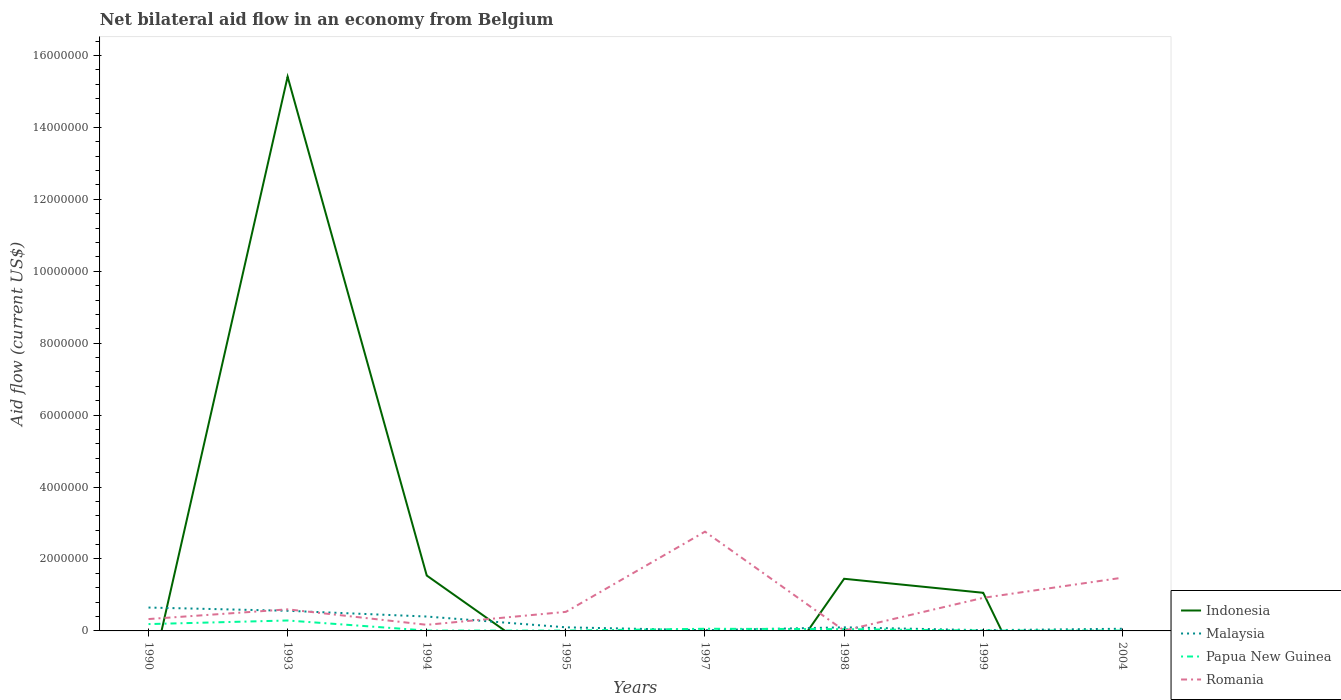Does the line corresponding to Papua New Guinea intersect with the line corresponding to Romania?
Ensure brevity in your answer.  Yes. Across all years, what is the maximum net bilateral aid flow in Malaysia?
Provide a short and direct response. 2.00e+04. What is the total net bilateral aid flow in Indonesia in the graph?
Your answer should be very brief. 9.00e+04. What is the difference between the highest and the second highest net bilateral aid flow in Papua New Guinea?
Your answer should be very brief. 2.80e+05. Is the net bilateral aid flow in Romania strictly greater than the net bilateral aid flow in Papua New Guinea over the years?
Your answer should be very brief. No. How many years are there in the graph?
Your response must be concise. 8. What is the difference between two consecutive major ticks on the Y-axis?
Make the answer very short. 2.00e+06. Are the values on the major ticks of Y-axis written in scientific E-notation?
Your answer should be compact. No. What is the title of the graph?
Your response must be concise. Net bilateral aid flow in an economy from Belgium. Does "Cabo Verde" appear as one of the legend labels in the graph?
Your answer should be very brief. No. What is the label or title of the X-axis?
Provide a short and direct response. Years. What is the Aid flow (current US$) in Indonesia in 1990?
Provide a succinct answer. 0. What is the Aid flow (current US$) in Malaysia in 1990?
Your answer should be very brief. 6.50e+05. What is the Aid flow (current US$) of Indonesia in 1993?
Your answer should be very brief. 1.54e+07. What is the Aid flow (current US$) of Malaysia in 1993?
Provide a succinct answer. 5.60e+05. What is the Aid flow (current US$) of Papua New Guinea in 1993?
Ensure brevity in your answer.  2.90e+05. What is the Aid flow (current US$) of Indonesia in 1994?
Your response must be concise. 1.54e+06. What is the Aid flow (current US$) of Romania in 1994?
Your answer should be very brief. 1.70e+05. What is the Aid flow (current US$) of Indonesia in 1995?
Provide a short and direct response. 0. What is the Aid flow (current US$) of Papua New Guinea in 1995?
Your answer should be very brief. 10000. What is the Aid flow (current US$) of Romania in 1995?
Offer a very short reply. 5.30e+05. What is the Aid flow (current US$) in Romania in 1997?
Your response must be concise. 2.76e+06. What is the Aid flow (current US$) of Indonesia in 1998?
Offer a very short reply. 1.45e+06. What is the Aid flow (current US$) in Romania in 1998?
Offer a very short reply. 10000. What is the Aid flow (current US$) of Indonesia in 1999?
Offer a terse response. 1.06e+06. What is the Aid flow (current US$) of Romania in 1999?
Your answer should be compact. 9.20e+05. What is the Aid flow (current US$) in Indonesia in 2004?
Ensure brevity in your answer.  0. What is the Aid flow (current US$) in Malaysia in 2004?
Offer a very short reply. 6.00e+04. What is the Aid flow (current US$) of Romania in 2004?
Make the answer very short. 1.48e+06. Across all years, what is the maximum Aid flow (current US$) in Indonesia?
Provide a succinct answer. 1.54e+07. Across all years, what is the maximum Aid flow (current US$) of Malaysia?
Keep it short and to the point. 6.50e+05. Across all years, what is the maximum Aid flow (current US$) in Papua New Guinea?
Give a very brief answer. 2.90e+05. Across all years, what is the maximum Aid flow (current US$) in Romania?
Offer a terse response. 2.76e+06. Across all years, what is the minimum Aid flow (current US$) of Papua New Guinea?
Provide a short and direct response. 10000. What is the total Aid flow (current US$) in Indonesia in the graph?
Offer a very short reply. 1.95e+07. What is the total Aid flow (current US$) of Malaysia in the graph?
Your answer should be very brief. 1.91e+06. What is the total Aid flow (current US$) in Papua New Guinea in the graph?
Provide a succinct answer. 6.30e+05. What is the total Aid flow (current US$) in Romania in the graph?
Provide a succinct answer. 6.80e+06. What is the difference between the Aid flow (current US$) in Papua New Guinea in 1990 and that in 1993?
Your answer should be compact. -1.00e+05. What is the difference between the Aid flow (current US$) of Malaysia in 1990 and that in 1995?
Your response must be concise. 5.50e+05. What is the difference between the Aid flow (current US$) in Romania in 1990 and that in 1995?
Offer a very short reply. -2.00e+05. What is the difference between the Aid flow (current US$) in Malaysia in 1990 and that in 1997?
Offer a terse response. 6.30e+05. What is the difference between the Aid flow (current US$) of Romania in 1990 and that in 1997?
Your answer should be compact. -2.43e+06. What is the difference between the Aid flow (current US$) in Malaysia in 1990 and that in 1999?
Offer a terse response. 6.30e+05. What is the difference between the Aid flow (current US$) of Romania in 1990 and that in 1999?
Give a very brief answer. -5.90e+05. What is the difference between the Aid flow (current US$) of Malaysia in 1990 and that in 2004?
Provide a short and direct response. 5.90e+05. What is the difference between the Aid flow (current US$) in Romania in 1990 and that in 2004?
Your answer should be compact. -1.15e+06. What is the difference between the Aid flow (current US$) in Indonesia in 1993 and that in 1994?
Ensure brevity in your answer.  1.39e+07. What is the difference between the Aid flow (current US$) in Papua New Guinea in 1993 and that in 1994?
Ensure brevity in your answer.  2.80e+05. What is the difference between the Aid flow (current US$) of Romania in 1993 and that in 1994?
Keep it short and to the point. 4.30e+05. What is the difference between the Aid flow (current US$) in Malaysia in 1993 and that in 1997?
Offer a terse response. 5.40e+05. What is the difference between the Aid flow (current US$) in Papua New Guinea in 1993 and that in 1997?
Provide a short and direct response. 2.30e+05. What is the difference between the Aid flow (current US$) in Romania in 1993 and that in 1997?
Offer a very short reply. -2.16e+06. What is the difference between the Aid flow (current US$) of Indonesia in 1993 and that in 1998?
Your answer should be very brief. 1.40e+07. What is the difference between the Aid flow (current US$) in Papua New Guinea in 1993 and that in 1998?
Ensure brevity in your answer.  2.40e+05. What is the difference between the Aid flow (current US$) in Romania in 1993 and that in 1998?
Your answer should be very brief. 5.90e+05. What is the difference between the Aid flow (current US$) in Indonesia in 1993 and that in 1999?
Ensure brevity in your answer.  1.44e+07. What is the difference between the Aid flow (current US$) of Malaysia in 1993 and that in 1999?
Your answer should be compact. 5.40e+05. What is the difference between the Aid flow (current US$) of Romania in 1993 and that in 1999?
Keep it short and to the point. -3.20e+05. What is the difference between the Aid flow (current US$) of Papua New Guinea in 1993 and that in 2004?
Offer a very short reply. 2.80e+05. What is the difference between the Aid flow (current US$) of Romania in 1993 and that in 2004?
Provide a succinct answer. -8.80e+05. What is the difference between the Aid flow (current US$) of Papua New Guinea in 1994 and that in 1995?
Give a very brief answer. 0. What is the difference between the Aid flow (current US$) in Romania in 1994 and that in 1995?
Offer a very short reply. -3.60e+05. What is the difference between the Aid flow (current US$) in Romania in 1994 and that in 1997?
Provide a short and direct response. -2.59e+06. What is the difference between the Aid flow (current US$) of Indonesia in 1994 and that in 1998?
Your answer should be very brief. 9.00e+04. What is the difference between the Aid flow (current US$) in Romania in 1994 and that in 1998?
Offer a very short reply. 1.60e+05. What is the difference between the Aid flow (current US$) in Indonesia in 1994 and that in 1999?
Provide a short and direct response. 4.80e+05. What is the difference between the Aid flow (current US$) in Malaysia in 1994 and that in 1999?
Provide a succinct answer. 3.80e+05. What is the difference between the Aid flow (current US$) in Papua New Guinea in 1994 and that in 1999?
Your answer should be compact. 0. What is the difference between the Aid flow (current US$) of Romania in 1994 and that in 1999?
Keep it short and to the point. -7.50e+05. What is the difference between the Aid flow (current US$) of Malaysia in 1994 and that in 2004?
Your answer should be compact. 3.40e+05. What is the difference between the Aid flow (current US$) in Romania in 1994 and that in 2004?
Provide a succinct answer. -1.31e+06. What is the difference between the Aid flow (current US$) of Malaysia in 1995 and that in 1997?
Give a very brief answer. 8.00e+04. What is the difference between the Aid flow (current US$) of Papua New Guinea in 1995 and that in 1997?
Offer a very short reply. -5.00e+04. What is the difference between the Aid flow (current US$) of Romania in 1995 and that in 1997?
Give a very brief answer. -2.23e+06. What is the difference between the Aid flow (current US$) in Romania in 1995 and that in 1998?
Your answer should be compact. 5.20e+05. What is the difference between the Aid flow (current US$) of Malaysia in 1995 and that in 1999?
Your answer should be compact. 8.00e+04. What is the difference between the Aid flow (current US$) in Romania in 1995 and that in 1999?
Offer a terse response. -3.90e+05. What is the difference between the Aid flow (current US$) in Papua New Guinea in 1995 and that in 2004?
Keep it short and to the point. 0. What is the difference between the Aid flow (current US$) in Romania in 1995 and that in 2004?
Your answer should be very brief. -9.50e+05. What is the difference between the Aid flow (current US$) in Papua New Guinea in 1997 and that in 1998?
Provide a short and direct response. 10000. What is the difference between the Aid flow (current US$) in Romania in 1997 and that in 1998?
Ensure brevity in your answer.  2.75e+06. What is the difference between the Aid flow (current US$) in Romania in 1997 and that in 1999?
Ensure brevity in your answer.  1.84e+06. What is the difference between the Aid flow (current US$) in Malaysia in 1997 and that in 2004?
Your response must be concise. -4.00e+04. What is the difference between the Aid flow (current US$) in Romania in 1997 and that in 2004?
Offer a terse response. 1.28e+06. What is the difference between the Aid flow (current US$) of Indonesia in 1998 and that in 1999?
Keep it short and to the point. 3.90e+05. What is the difference between the Aid flow (current US$) of Malaysia in 1998 and that in 1999?
Offer a terse response. 8.00e+04. What is the difference between the Aid flow (current US$) of Romania in 1998 and that in 1999?
Offer a terse response. -9.10e+05. What is the difference between the Aid flow (current US$) in Romania in 1998 and that in 2004?
Give a very brief answer. -1.47e+06. What is the difference between the Aid flow (current US$) in Romania in 1999 and that in 2004?
Provide a succinct answer. -5.60e+05. What is the difference between the Aid flow (current US$) of Malaysia in 1990 and the Aid flow (current US$) of Papua New Guinea in 1993?
Offer a very short reply. 3.60e+05. What is the difference between the Aid flow (current US$) of Papua New Guinea in 1990 and the Aid flow (current US$) of Romania in 1993?
Your answer should be compact. -4.10e+05. What is the difference between the Aid flow (current US$) of Malaysia in 1990 and the Aid flow (current US$) of Papua New Guinea in 1994?
Your answer should be very brief. 6.40e+05. What is the difference between the Aid flow (current US$) of Malaysia in 1990 and the Aid flow (current US$) of Papua New Guinea in 1995?
Your answer should be very brief. 6.40e+05. What is the difference between the Aid flow (current US$) in Papua New Guinea in 1990 and the Aid flow (current US$) in Romania in 1995?
Your answer should be compact. -3.40e+05. What is the difference between the Aid flow (current US$) in Malaysia in 1990 and the Aid flow (current US$) in Papua New Guinea in 1997?
Ensure brevity in your answer.  5.90e+05. What is the difference between the Aid flow (current US$) in Malaysia in 1990 and the Aid flow (current US$) in Romania in 1997?
Your response must be concise. -2.11e+06. What is the difference between the Aid flow (current US$) in Papua New Guinea in 1990 and the Aid flow (current US$) in Romania in 1997?
Your answer should be very brief. -2.57e+06. What is the difference between the Aid flow (current US$) in Malaysia in 1990 and the Aid flow (current US$) in Romania in 1998?
Give a very brief answer. 6.40e+05. What is the difference between the Aid flow (current US$) of Papua New Guinea in 1990 and the Aid flow (current US$) of Romania in 1998?
Provide a succinct answer. 1.80e+05. What is the difference between the Aid flow (current US$) in Malaysia in 1990 and the Aid flow (current US$) in Papua New Guinea in 1999?
Give a very brief answer. 6.40e+05. What is the difference between the Aid flow (current US$) of Malaysia in 1990 and the Aid flow (current US$) of Romania in 1999?
Your answer should be very brief. -2.70e+05. What is the difference between the Aid flow (current US$) in Papua New Guinea in 1990 and the Aid flow (current US$) in Romania in 1999?
Offer a very short reply. -7.30e+05. What is the difference between the Aid flow (current US$) in Malaysia in 1990 and the Aid flow (current US$) in Papua New Guinea in 2004?
Your response must be concise. 6.40e+05. What is the difference between the Aid flow (current US$) of Malaysia in 1990 and the Aid flow (current US$) of Romania in 2004?
Your answer should be compact. -8.30e+05. What is the difference between the Aid flow (current US$) in Papua New Guinea in 1990 and the Aid flow (current US$) in Romania in 2004?
Offer a very short reply. -1.29e+06. What is the difference between the Aid flow (current US$) of Indonesia in 1993 and the Aid flow (current US$) of Malaysia in 1994?
Give a very brief answer. 1.50e+07. What is the difference between the Aid flow (current US$) in Indonesia in 1993 and the Aid flow (current US$) in Papua New Guinea in 1994?
Give a very brief answer. 1.54e+07. What is the difference between the Aid flow (current US$) in Indonesia in 1993 and the Aid flow (current US$) in Romania in 1994?
Give a very brief answer. 1.52e+07. What is the difference between the Aid flow (current US$) of Malaysia in 1993 and the Aid flow (current US$) of Papua New Guinea in 1994?
Give a very brief answer. 5.50e+05. What is the difference between the Aid flow (current US$) of Malaysia in 1993 and the Aid flow (current US$) of Romania in 1994?
Give a very brief answer. 3.90e+05. What is the difference between the Aid flow (current US$) of Papua New Guinea in 1993 and the Aid flow (current US$) of Romania in 1994?
Keep it short and to the point. 1.20e+05. What is the difference between the Aid flow (current US$) in Indonesia in 1993 and the Aid flow (current US$) in Malaysia in 1995?
Provide a short and direct response. 1.53e+07. What is the difference between the Aid flow (current US$) in Indonesia in 1993 and the Aid flow (current US$) in Papua New Guinea in 1995?
Offer a terse response. 1.54e+07. What is the difference between the Aid flow (current US$) in Indonesia in 1993 and the Aid flow (current US$) in Romania in 1995?
Provide a succinct answer. 1.49e+07. What is the difference between the Aid flow (current US$) in Malaysia in 1993 and the Aid flow (current US$) in Papua New Guinea in 1995?
Keep it short and to the point. 5.50e+05. What is the difference between the Aid flow (current US$) in Malaysia in 1993 and the Aid flow (current US$) in Romania in 1995?
Ensure brevity in your answer.  3.00e+04. What is the difference between the Aid flow (current US$) in Papua New Guinea in 1993 and the Aid flow (current US$) in Romania in 1995?
Keep it short and to the point. -2.40e+05. What is the difference between the Aid flow (current US$) in Indonesia in 1993 and the Aid flow (current US$) in Malaysia in 1997?
Your response must be concise. 1.54e+07. What is the difference between the Aid flow (current US$) of Indonesia in 1993 and the Aid flow (current US$) of Papua New Guinea in 1997?
Your answer should be very brief. 1.54e+07. What is the difference between the Aid flow (current US$) of Indonesia in 1993 and the Aid flow (current US$) of Romania in 1997?
Offer a very short reply. 1.26e+07. What is the difference between the Aid flow (current US$) in Malaysia in 1993 and the Aid flow (current US$) in Papua New Guinea in 1997?
Your response must be concise. 5.00e+05. What is the difference between the Aid flow (current US$) of Malaysia in 1993 and the Aid flow (current US$) of Romania in 1997?
Your response must be concise. -2.20e+06. What is the difference between the Aid flow (current US$) of Papua New Guinea in 1993 and the Aid flow (current US$) of Romania in 1997?
Provide a succinct answer. -2.47e+06. What is the difference between the Aid flow (current US$) in Indonesia in 1993 and the Aid flow (current US$) in Malaysia in 1998?
Your response must be concise. 1.53e+07. What is the difference between the Aid flow (current US$) of Indonesia in 1993 and the Aid flow (current US$) of Papua New Guinea in 1998?
Your answer should be compact. 1.54e+07. What is the difference between the Aid flow (current US$) in Indonesia in 1993 and the Aid flow (current US$) in Romania in 1998?
Offer a terse response. 1.54e+07. What is the difference between the Aid flow (current US$) of Malaysia in 1993 and the Aid flow (current US$) of Papua New Guinea in 1998?
Give a very brief answer. 5.10e+05. What is the difference between the Aid flow (current US$) in Malaysia in 1993 and the Aid flow (current US$) in Romania in 1998?
Provide a short and direct response. 5.50e+05. What is the difference between the Aid flow (current US$) in Indonesia in 1993 and the Aid flow (current US$) in Malaysia in 1999?
Keep it short and to the point. 1.54e+07. What is the difference between the Aid flow (current US$) of Indonesia in 1993 and the Aid flow (current US$) of Papua New Guinea in 1999?
Make the answer very short. 1.54e+07. What is the difference between the Aid flow (current US$) of Indonesia in 1993 and the Aid flow (current US$) of Romania in 1999?
Your answer should be compact. 1.45e+07. What is the difference between the Aid flow (current US$) in Malaysia in 1993 and the Aid flow (current US$) in Papua New Guinea in 1999?
Your response must be concise. 5.50e+05. What is the difference between the Aid flow (current US$) of Malaysia in 1993 and the Aid flow (current US$) of Romania in 1999?
Offer a very short reply. -3.60e+05. What is the difference between the Aid flow (current US$) in Papua New Guinea in 1993 and the Aid flow (current US$) in Romania in 1999?
Your answer should be very brief. -6.30e+05. What is the difference between the Aid flow (current US$) in Indonesia in 1993 and the Aid flow (current US$) in Malaysia in 2004?
Your answer should be compact. 1.54e+07. What is the difference between the Aid flow (current US$) of Indonesia in 1993 and the Aid flow (current US$) of Papua New Guinea in 2004?
Your response must be concise. 1.54e+07. What is the difference between the Aid flow (current US$) of Indonesia in 1993 and the Aid flow (current US$) of Romania in 2004?
Ensure brevity in your answer.  1.39e+07. What is the difference between the Aid flow (current US$) of Malaysia in 1993 and the Aid flow (current US$) of Papua New Guinea in 2004?
Your answer should be compact. 5.50e+05. What is the difference between the Aid flow (current US$) in Malaysia in 1993 and the Aid flow (current US$) in Romania in 2004?
Offer a very short reply. -9.20e+05. What is the difference between the Aid flow (current US$) of Papua New Guinea in 1993 and the Aid flow (current US$) of Romania in 2004?
Provide a succinct answer. -1.19e+06. What is the difference between the Aid flow (current US$) of Indonesia in 1994 and the Aid flow (current US$) of Malaysia in 1995?
Your answer should be very brief. 1.44e+06. What is the difference between the Aid flow (current US$) in Indonesia in 1994 and the Aid flow (current US$) in Papua New Guinea in 1995?
Offer a terse response. 1.53e+06. What is the difference between the Aid flow (current US$) in Indonesia in 1994 and the Aid flow (current US$) in Romania in 1995?
Keep it short and to the point. 1.01e+06. What is the difference between the Aid flow (current US$) in Malaysia in 1994 and the Aid flow (current US$) in Romania in 1995?
Provide a short and direct response. -1.30e+05. What is the difference between the Aid flow (current US$) of Papua New Guinea in 1994 and the Aid flow (current US$) of Romania in 1995?
Your answer should be compact. -5.20e+05. What is the difference between the Aid flow (current US$) in Indonesia in 1994 and the Aid flow (current US$) in Malaysia in 1997?
Offer a terse response. 1.52e+06. What is the difference between the Aid flow (current US$) in Indonesia in 1994 and the Aid flow (current US$) in Papua New Guinea in 1997?
Offer a terse response. 1.48e+06. What is the difference between the Aid flow (current US$) of Indonesia in 1994 and the Aid flow (current US$) of Romania in 1997?
Provide a succinct answer. -1.22e+06. What is the difference between the Aid flow (current US$) in Malaysia in 1994 and the Aid flow (current US$) in Romania in 1997?
Give a very brief answer. -2.36e+06. What is the difference between the Aid flow (current US$) in Papua New Guinea in 1994 and the Aid flow (current US$) in Romania in 1997?
Provide a short and direct response. -2.75e+06. What is the difference between the Aid flow (current US$) of Indonesia in 1994 and the Aid flow (current US$) of Malaysia in 1998?
Your answer should be very brief. 1.44e+06. What is the difference between the Aid flow (current US$) of Indonesia in 1994 and the Aid flow (current US$) of Papua New Guinea in 1998?
Provide a succinct answer. 1.49e+06. What is the difference between the Aid flow (current US$) of Indonesia in 1994 and the Aid flow (current US$) of Romania in 1998?
Provide a short and direct response. 1.53e+06. What is the difference between the Aid flow (current US$) of Malaysia in 1994 and the Aid flow (current US$) of Romania in 1998?
Offer a very short reply. 3.90e+05. What is the difference between the Aid flow (current US$) in Indonesia in 1994 and the Aid flow (current US$) in Malaysia in 1999?
Your answer should be very brief. 1.52e+06. What is the difference between the Aid flow (current US$) of Indonesia in 1994 and the Aid flow (current US$) of Papua New Guinea in 1999?
Give a very brief answer. 1.53e+06. What is the difference between the Aid flow (current US$) of Indonesia in 1994 and the Aid flow (current US$) of Romania in 1999?
Give a very brief answer. 6.20e+05. What is the difference between the Aid flow (current US$) in Malaysia in 1994 and the Aid flow (current US$) in Papua New Guinea in 1999?
Keep it short and to the point. 3.90e+05. What is the difference between the Aid flow (current US$) of Malaysia in 1994 and the Aid flow (current US$) of Romania in 1999?
Your answer should be very brief. -5.20e+05. What is the difference between the Aid flow (current US$) in Papua New Guinea in 1994 and the Aid flow (current US$) in Romania in 1999?
Provide a succinct answer. -9.10e+05. What is the difference between the Aid flow (current US$) in Indonesia in 1994 and the Aid flow (current US$) in Malaysia in 2004?
Give a very brief answer. 1.48e+06. What is the difference between the Aid flow (current US$) of Indonesia in 1994 and the Aid flow (current US$) of Papua New Guinea in 2004?
Your answer should be compact. 1.53e+06. What is the difference between the Aid flow (current US$) of Indonesia in 1994 and the Aid flow (current US$) of Romania in 2004?
Provide a succinct answer. 6.00e+04. What is the difference between the Aid flow (current US$) of Malaysia in 1994 and the Aid flow (current US$) of Romania in 2004?
Your answer should be very brief. -1.08e+06. What is the difference between the Aid flow (current US$) of Papua New Guinea in 1994 and the Aid flow (current US$) of Romania in 2004?
Offer a very short reply. -1.47e+06. What is the difference between the Aid flow (current US$) of Malaysia in 1995 and the Aid flow (current US$) of Romania in 1997?
Your answer should be very brief. -2.66e+06. What is the difference between the Aid flow (current US$) in Papua New Guinea in 1995 and the Aid flow (current US$) in Romania in 1997?
Provide a short and direct response. -2.75e+06. What is the difference between the Aid flow (current US$) of Malaysia in 1995 and the Aid flow (current US$) of Papua New Guinea in 1998?
Offer a very short reply. 5.00e+04. What is the difference between the Aid flow (current US$) in Malaysia in 1995 and the Aid flow (current US$) in Romania in 1998?
Offer a terse response. 9.00e+04. What is the difference between the Aid flow (current US$) in Malaysia in 1995 and the Aid flow (current US$) in Romania in 1999?
Ensure brevity in your answer.  -8.20e+05. What is the difference between the Aid flow (current US$) in Papua New Guinea in 1995 and the Aid flow (current US$) in Romania in 1999?
Offer a terse response. -9.10e+05. What is the difference between the Aid flow (current US$) of Malaysia in 1995 and the Aid flow (current US$) of Romania in 2004?
Your answer should be compact. -1.38e+06. What is the difference between the Aid flow (current US$) of Papua New Guinea in 1995 and the Aid flow (current US$) of Romania in 2004?
Provide a succinct answer. -1.47e+06. What is the difference between the Aid flow (current US$) in Malaysia in 1997 and the Aid flow (current US$) in Papua New Guinea in 1998?
Offer a very short reply. -3.00e+04. What is the difference between the Aid flow (current US$) in Malaysia in 1997 and the Aid flow (current US$) in Romania in 1998?
Your response must be concise. 10000. What is the difference between the Aid flow (current US$) of Malaysia in 1997 and the Aid flow (current US$) of Papua New Guinea in 1999?
Keep it short and to the point. 10000. What is the difference between the Aid flow (current US$) of Malaysia in 1997 and the Aid flow (current US$) of Romania in 1999?
Keep it short and to the point. -9.00e+05. What is the difference between the Aid flow (current US$) of Papua New Guinea in 1997 and the Aid flow (current US$) of Romania in 1999?
Ensure brevity in your answer.  -8.60e+05. What is the difference between the Aid flow (current US$) in Malaysia in 1997 and the Aid flow (current US$) in Papua New Guinea in 2004?
Your answer should be compact. 10000. What is the difference between the Aid flow (current US$) of Malaysia in 1997 and the Aid flow (current US$) of Romania in 2004?
Your answer should be very brief. -1.46e+06. What is the difference between the Aid flow (current US$) of Papua New Guinea in 1997 and the Aid flow (current US$) of Romania in 2004?
Your response must be concise. -1.42e+06. What is the difference between the Aid flow (current US$) in Indonesia in 1998 and the Aid flow (current US$) in Malaysia in 1999?
Keep it short and to the point. 1.43e+06. What is the difference between the Aid flow (current US$) in Indonesia in 1998 and the Aid flow (current US$) in Papua New Guinea in 1999?
Keep it short and to the point. 1.44e+06. What is the difference between the Aid flow (current US$) in Indonesia in 1998 and the Aid flow (current US$) in Romania in 1999?
Make the answer very short. 5.30e+05. What is the difference between the Aid flow (current US$) in Malaysia in 1998 and the Aid flow (current US$) in Papua New Guinea in 1999?
Keep it short and to the point. 9.00e+04. What is the difference between the Aid flow (current US$) of Malaysia in 1998 and the Aid flow (current US$) of Romania in 1999?
Make the answer very short. -8.20e+05. What is the difference between the Aid flow (current US$) of Papua New Guinea in 1998 and the Aid flow (current US$) of Romania in 1999?
Your response must be concise. -8.70e+05. What is the difference between the Aid flow (current US$) of Indonesia in 1998 and the Aid flow (current US$) of Malaysia in 2004?
Your response must be concise. 1.39e+06. What is the difference between the Aid flow (current US$) in Indonesia in 1998 and the Aid flow (current US$) in Papua New Guinea in 2004?
Provide a succinct answer. 1.44e+06. What is the difference between the Aid flow (current US$) in Indonesia in 1998 and the Aid flow (current US$) in Romania in 2004?
Offer a terse response. -3.00e+04. What is the difference between the Aid flow (current US$) in Malaysia in 1998 and the Aid flow (current US$) in Papua New Guinea in 2004?
Make the answer very short. 9.00e+04. What is the difference between the Aid flow (current US$) of Malaysia in 1998 and the Aid flow (current US$) of Romania in 2004?
Your response must be concise. -1.38e+06. What is the difference between the Aid flow (current US$) of Papua New Guinea in 1998 and the Aid flow (current US$) of Romania in 2004?
Your response must be concise. -1.43e+06. What is the difference between the Aid flow (current US$) in Indonesia in 1999 and the Aid flow (current US$) in Malaysia in 2004?
Provide a short and direct response. 1.00e+06. What is the difference between the Aid flow (current US$) of Indonesia in 1999 and the Aid flow (current US$) of Papua New Guinea in 2004?
Make the answer very short. 1.05e+06. What is the difference between the Aid flow (current US$) of Indonesia in 1999 and the Aid flow (current US$) of Romania in 2004?
Make the answer very short. -4.20e+05. What is the difference between the Aid flow (current US$) of Malaysia in 1999 and the Aid flow (current US$) of Papua New Guinea in 2004?
Your response must be concise. 10000. What is the difference between the Aid flow (current US$) of Malaysia in 1999 and the Aid flow (current US$) of Romania in 2004?
Keep it short and to the point. -1.46e+06. What is the difference between the Aid flow (current US$) in Papua New Guinea in 1999 and the Aid flow (current US$) in Romania in 2004?
Offer a very short reply. -1.47e+06. What is the average Aid flow (current US$) in Indonesia per year?
Offer a very short reply. 2.43e+06. What is the average Aid flow (current US$) of Malaysia per year?
Provide a succinct answer. 2.39e+05. What is the average Aid flow (current US$) of Papua New Guinea per year?
Your answer should be very brief. 7.88e+04. What is the average Aid flow (current US$) of Romania per year?
Your answer should be very brief. 8.50e+05. In the year 1990, what is the difference between the Aid flow (current US$) in Malaysia and Aid flow (current US$) in Papua New Guinea?
Your answer should be very brief. 4.60e+05. In the year 1990, what is the difference between the Aid flow (current US$) of Malaysia and Aid flow (current US$) of Romania?
Provide a short and direct response. 3.20e+05. In the year 1993, what is the difference between the Aid flow (current US$) in Indonesia and Aid flow (current US$) in Malaysia?
Provide a short and direct response. 1.48e+07. In the year 1993, what is the difference between the Aid flow (current US$) of Indonesia and Aid flow (current US$) of Papua New Guinea?
Give a very brief answer. 1.51e+07. In the year 1993, what is the difference between the Aid flow (current US$) of Indonesia and Aid flow (current US$) of Romania?
Ensure brevity in your answer.  1.48e+07. In the year 1993, what is the difference between the Aid flow (current US$) in Malaysia and Aid flow (current US$) in Papua New Guinea?
Make the answer very short. 2.70e+05. In the year 1993, what is the difference between the Aid flow (current US$) in Malaysia and Aid flow (current US$) in Romania?
Your response must be concise. -4.00e+04. In the year 1993, what is the difference between the Aid flow (current US$) in Papua New Guinea and Aid flow (current US$) in Romania?
Provide a short and direct response. -3.10e+05. In the year 1994, what is the difference between the Aid flow (current US$) of Indonesia and Aid flow (current US$) of Malaysia?
Keep it short and to the point. 1.14e+06. In the year 1994, what is the difference between the Aid flow (current US$) of Indonesia and Aid flow (current US$) of Papua New Guinea?
Make the answer very short. 1.53e+06. In the year 1994, what is the difference between the Aid flow (current US$) in Indonesia and Aid flow (current US$) in Romania?
Keep it short and to the point. 1.37e+06. In the year 1994, what is the difference between the Aid flow (current US$) in Malaysia and Aid flow (current US$) in Papua New Guinea?
Give a very brief answer. 3.90e+05. In the year 1994, what is the difference between the Aid flow (current US$) of Malaysia and Aid flow (current US$) of Romania?
Ensure brevity in your answer.  2.30e+05. In the year 1994, what is the difference between the Aid flow (current US$) in Papua New Guinea and Aid flow (current US$) in Romania?
Give a very brief answer. -1.60e+05. In the year 1995, what is the difference between the Aid flow (current US$) in Malaysia and Aid flow (current US$) in Romania?
Give a very brief answer. -4.30e+05. In the year 1995, what is the difference between the Aid flow (current US$) in Papua New Guinea and Aid flow (current US$) in Romania?
Provide a short and direct response. -5.20e+05. In the year 1997, what is the difference between the Aid flow (current US$) in Malaysia and Aid flow (current US$) in Romania?
Provide a short and direct response. -2.74e+06. In the year 1997, what is the difference between the Aid flow (current US$) in Papua New Guinea and Aid flow (current US$) in Romania?
Ensure brevity in your answer.  -2.70e+06. In the year 1998, what is the difference between the Aid flow (current US$) of Indonesia and Aid flow (current US$) of Malaysia?
Offer a very short reply. 1.35e+06. In the year 1998, what is the difference between the Aid flow (current US$) of Indonesia and Aid flow (current US$) of Papua New Guinea?
Your answer should be very brief. 1.40e+06. In the year 1998, what is the difference between the Aid flow (current US$) of Indonesia and Aid flow (current US$) of Romania?
Provide a short and direct response. 1.44e+06. In the year 1998, what is the difference between the Aid flow (current US$) of Malaysia and Aid flow (current US$) of Papua New Guinea?
Your answer should be very brief. 5.00e+04. In the year 1998, what is the difference between the Aid flow (current US$) in Malaysia and Aid flow (current US$) in Romania?
Your response must be concise. 9.00e+04. In the year 1999, what is the difference between the Aid flow (current US$) of Indonesia and Aid flow (current US$) of Malaysia?
Make the answer very short. 1.04e+06. In the year 1999, what is the difference between the Aid flow (current US$) of Indonesia and Aid flow (current US$) of Papua New Guinea?
Keep it short and to the point. 1.05e+06. In the year 1999, what is the difference between the Aid flow (current US$) in Indonesia and Aid flow (current US$) in Romania?
Provide a short and direct response. 1.40e+05. In the year 1999, what is the difference between the Aid flow (current US$) in Malaysia and Aid flow (current US$) in Papua New Guinea?
Keep it short and to the point. 10000. In the year 1999, what is the difference between the Aid flow (current US$) of Malaysia and Aid flow (current US$) of Romania?
Provide a succinct answer. -9.00e+05. In the year 1999, what is the difference between the Aid flow (current US$) in Papua New Guinea and Aid flow (current US$) in Romania?
Give a very brief answer. -9.10e+05. In the year 2004, what is the difference between the Aid flow (current US$) in Malaysia and Aid flow (current US$) in Romania?
Provide a short and direct response. -1.42e+06. In the year 2004, what is the difference between the Aid flow (current US$) in Papua New Guinea and Aid flow (current US$) in Romania?
Your response must be concise. -1.47e+06. What is the ratio of the Aid flow (current US$) in Malaysia in 1990 to that in 1993?
Provide a succinct answer. 1.16. What is the ratio of the Aid flow (current US$) in Papua New Guinea in 1990 to that in 1993?
Offer a very short reply. 0.66. What is the ratio of the Aid flow (current US$) in Romania in 1990 to that in 1993?
Offer a terse response. 0.55. What is the ratio of the Aid flow (current US$) of Malaysia in 1990 to that in 1994?
Keep it short and to the point. 1.62. What is the ratio of the Aid flow (current US$) of Romania in 1990 to that in 1994?
Keep it short and to the point. 1.94. What is the ratio of the Aid flow (current US$) of Romania in 1990 to that in 1995?
Provide a succinct answer. 0.62. What is the ratio of the Aid flow (current US$) in Malaysia in 1990 to that in 1997?
Provide a short and direct response. 32.5. What is the ratio of the Aid flow (current US$) in Papua New Guinea in 1990 to that in 1997?
Make the answer very short. 3.17. What is the ratio of the Aid flow (current US$) in Romania in 1990 to that in 1997?
Your response must be concise. 0.12. What is the ratio of the Aid flow (current US$) of Papua New Guinea in 1990 to that in 1998?
Your answer should be compact. 3.8. What is the ratio of the Aid flow (current US$) of Romania in 1990 to that in 1998?
Give a very brief answer. 33. What is the ratio of the Aid flow (current US$) of Malaysia in 1990 to that in 1999?
Keep it short and to the point. 32.5. What is the ratio of the Aid flow (current US$) of Romania in 1990 to that in 1999?
Your response must be concise. 0.36. What is the ratio of the Aid flow (current US$) in Malaysia in 1990 to that in 2004?
Keep it short and to the point. 10.83. What is the ratio of the Aid flow (current US$) of Papua New Guinea in 1990 to that in 2004?
Give a very brief answer. 19. What is the ratio of the Aid flow (current US$) in Romania in 1990 to that in 2004?
Offer a very short reply. 0.22. What is the ratio of the Aid flow (current US$) in Indonesia in 1993 to that in 1994?
Your answer should be very brief. 10.01. What is the ratio of the Aid flow (current US$) in Malaysia in 1993 to that in 1994?
Your answer should be very brief. 1.4. What is the ratio of the Aid flow (current US$) in Papua New Guinea in 1993 to that in 1994?
Offer a very short reply. 29. What is the ratio of the Aid flow (current US$) of Romania in 1993 to that in 1994?
Give a very brief answer. 3.53. What is the ratio of the Aid flow (current US$) of Malaysia in 1993 to that in 1995?
Make the answer very short. 5.6. What is the ratio of the Aid flow (current US$) in Papua New Guinea in 1993 to that in 1995?
Make the answer very short. 29. What is the ratio of the Aid flow (current US$) in Romania in 1993 to that in 1995?
Offer a very short reply. 1.13. What is the ratio of the Aid flow (current US$) of Papua New Guinea in 1993 to that in 1997?
Keep it short and to the point. 4.83. What is the ratio of the Aid flow (current US$) in Romania in 1993 to that in 1997?
Ensure brevity in your answer.  0.22. What is the ratio of the Aid flow (current US$) of Indonesia in 1993 to that in 1998?
Ensure brevity in your answer.  10.63. What is the ratio of the Aid flow (current US$) of Indonesia in 1993 to that in 1999?
Offer a very short reply. 14.54. What is the ratio of the Aid flow (current US$) in Papua New Guinea in 1993 to that in 1999?
Offer a very short reply. 29. What is the ratio of the Aid flow (current US$) of Romania in 1993 to that in 1999?
Your answer should be compact. 0.65. What is the ratio of the Aid flow (current US$) in Malaysia in 1993 to that in 2004?
Keep it short and to the point. 9.33. What is the ratio of the Aid flow (current US$) of Romania in 1993 to that in 2004?
Your answer should be compact. 0.41. What is the ratio of the Aid flow (current US$) in Papua New Guinea in 1994 to that in 1995?
Offer a terse response. 1. What is the ratio of the Aid flow (current US$) in Romania in 1994 to that in 1995?
Ensure brevity in your answer.  0.32. What is the ratio of the Aid flow (current US$) in Romania in 1994 to that in 1997?
Ensure brevity in your answer.  0.06. What is the ratio of the Aid flow (current US$) in Indonesia in 1994 to that in 1998?
Ensure brevity in your answer.  1.06. What is the ratio of the Aid flow (current US$) of Malaysia in 1994 to that in 1998?
Make the answer very short. 4. What is the ratio of the Aid flow (current US$) of Romania in 1994 to that in 1998?
Offer a very short reply. 17. What is the ratio of the Aid flow (current US$) in Indonesia in 1994 to that in 1999?
Your answer should be compact. 1.45. What is the ratio of the Aid flow (current US$) in Malaysia in 1994 to that in 1999?
Your answer should be very brief. 20. What is the ratio of the Aid flow (current US$) in Papua New Guinea in 1994 to that in 1999?
Make the answer very short. 1. What is the ratio of the Aid flow (current US$) in Romania in 1994 to that in 1999?
Your answer should be very brief. 0.18. What is the ratio of the Aid flow (current US$) in Malaysia in 1994 to that in 2004?
Ensure brevity in your answer.  6.67. What is the ratio of the Aid flow (current US$) in Papua New Guinea in 1994 to that in 2004?
Keep it short and to the point. 1. What is the ratio of the Aid flow (current US$) of Romania in 1994 to that in 2004?
Your answer should be compact. 0.11. What is the ratio of the Aid flow (current US$) of Papua New Guinea in 1995 to that in 1997?
Your response must be concise. 0.17. What is the ratio of the Aid flow (current US$) in Romania in 1995 to that in 1997?
Offer a very short reply. 0.19. What is the ratio of the Aid flow (current US$) in Papua New Guinea in 1995 to that in 1999?
Offer a very short reply. 1. What is the ratio of the Aid flow (current US$) of Romania in 1995 to that in 1999?
Give a very brief answer. 0.58. What is the ratio of the Aid flow (current US$) in Malaysia in 1995 to that in 2004?
Keep it short and to the point. 1.67. What is the ratio of the Aid flow (current US$) in Papua New Guinea in 1995 to that in 2004?
Make the answer very short. 1. What is the ratio of the Aid flow (current US$) of Romania in 1995 to that in 2004?
Provide a short and direct response. 0.36. What is the ratio of the Aid flow (current US$) in Romania in 1997 to that in 1998?
Provide a short and direct response. 276. What is the ratio of the Aid flow (current US$) of Papua New Guinea in 1997 to that in 2004?
Your answer should be compact. 6. What is the ratio of the Aid flow (current US$) of Romania in 1997 to that in 2004?
Offer a very short reply. 1.86. What is the ratio of the Aid flow (current US$) of Indonesia in 1998 to that in 1999?
Your answer should be compact. 1.37. What is the ratio of the Aid flow (current US$) of Papua New Guinea in 1998 to that in 1999?
Keep it short and to the point. 5. What is the ratio of the Aid flow (current US$) of Romania in 1998 to that in 1999?
Give a very brief answer. 0.01. What is the ratio of the Aid flow (current US$) in Romania in 1998 to that in 2004?
Keep it short and to the point. 0.01. What is the ratio of the Aid flow (current US$) of Malaysia in 1999 to that in 2004?
Keep it short and to the point. 0.33. What is the ratio of the Aid flow (current US$) of Papua New Guinea in 1999 to that in 2004?
Offer a very short reply. 1. What is the ratio of the Aid flow (current US$) in Romania in 1999 to that in 2004?
Your response must be concise. 0.62. What is the difference between the highest and the second highest Aid flow (current US$) of Indonesia?
Make the answer very short. 1.39e+07. What is the difference between the highest and the second highest Aid flow (current US$) of Romania?
Offer a terse response. 1.28e+06. What is the difference between the highest and the lowest Aid flow (current US$) in Indonesia?
Provide a succinct answer. 1.54e+07. What is the difference between the highest and the lowest Aid flow (current US$) of Malaysia?
Offer a terse response. 6.30e+05. What is the difference between the highest and the lowest Aid flow (current US$) in Romania?
Offer a very short reply. 2.75e+06. 